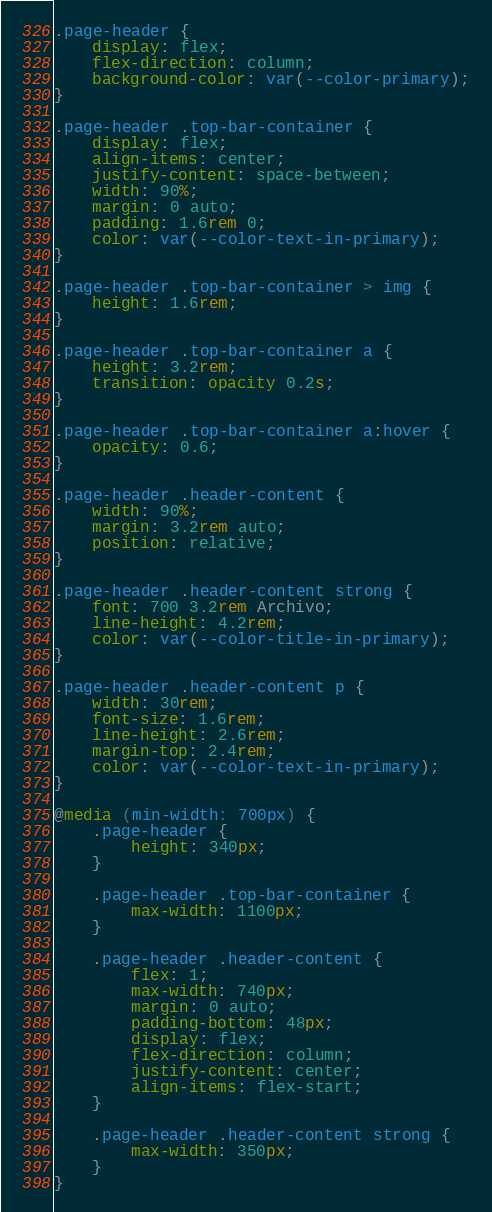<code> <loc_0><loc_0><loc_500><loc_500><_CSS_>.page-header {
    display: flex;
    flex-direction: column;
    background-color: var(--color-primary);
}

.page-header .top-bar-container {
    display: flex;
    align-items: center;
    justify-content: space-between;
    width: 90%;
    margin: 0 auto;
    padding: 1.6rem 0;
    color: var(--color-text-in-primary);
}

.page-header .top-bar-container > img {
    height: 1.6rem;
}

.page-header .top-bar-container a {
    height: 3.2rem;
    transition: opacity 0.2s;
}

.page-header .top-bar-container a:hover {
    opacity: 0.6;
}

.page-header .header-content {
    width: 90%;
    margin: 3.2rem auto;
    position: relative;
}

.page-header .header-content strong {
    font: 700 3.2rem Archivo;
    line-height: 4.2rem;
    color: var(--color-title-in-primary);
}

.page-header .header-content p {
    width: 30rem;
    font-size: 1.6rem;
    line-height: 2.6rem;
    margin-top: 2.4rem;
    color: var(--color-text-in-primary);
}

@media (min-width: 700px) {
    .page-header {
        height: 340px;
    }
    
    .page-header .top-bar-container {
        max-width: 1100px;
    }

    .page-header .header-content {
        flex: 1;
        max-width: 740px;
        margin: 0 auto;
        padding-bottom: 48px;
        display: flex;
        flex-direction: column;
        justify-content: center;
        align-items: flex-start;
    }

    .page-header .header-content strong {
        max-width: 350px;
    }
}</code> 